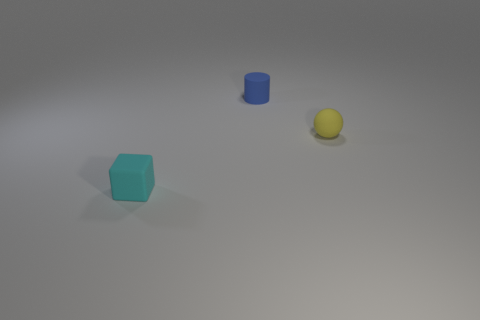Are there more objects in front of the tiny matte sphere than purple balls?
Ensure brevity in your answer.  Yes. The tiny thing that is left of the rubber thing behind the tiny thing on the right side of the blue thing is what color?
Keep it short and to the point. Cyan. Do the cyan matte cube and the blue object have the same size?
Provide a short and direct response. Yes. What number of cyan blocks have the same size as the cyan rubber object?
Offer a terse response. 0. Is the material of the small sphere that is in front of the small cylinder the same as the thing that is on the left side of the small cylinder?
Offer a very short reply. Yes. Are there any other things that have the same shape as the tiny yellow rubber thing?
Give a very brief answer. No. The cylinder has what color?
Give a very brief answer. Blue. What number of other tiny yellow rubber things have the same shape as the small yellow matte object?
Make the answer very short. 0. The rubber sphere that is the same size as the matte cylinder is what color?
Offer a very short reply. Yellow. Are any red balls visible?
Give a very brief answer. No. 